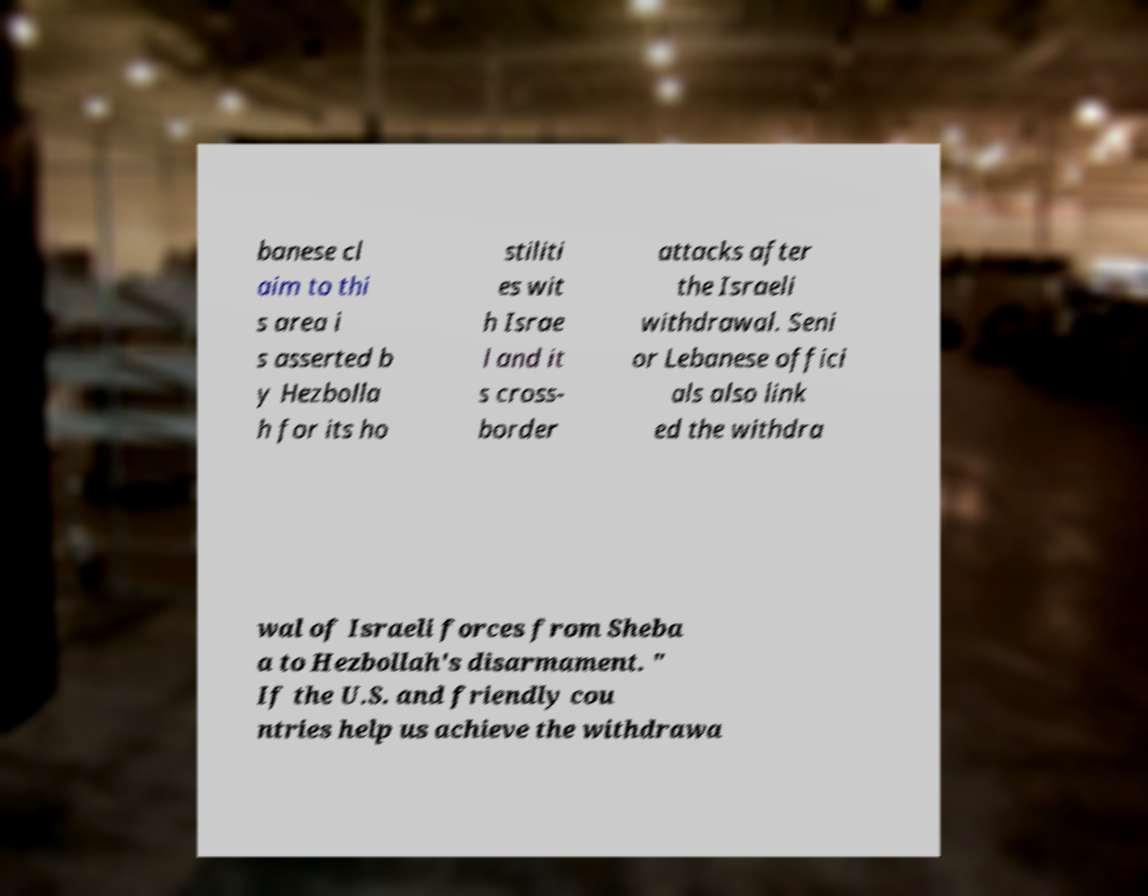Please identify and transcribe the text found in this image. banese cl aim to thi s area i s asserted b y Hezbolla h for its ho stiliti es wit h Israe l and it s cross- border attacks after the Israeli withdrawal. Seni or Lebanese offici als also link ed the withdra wal of Israeli forces from Sheba a to Hezbollah's disarmament. " If the U.S. and friendly cou ntries help us achieve the withdrawa 